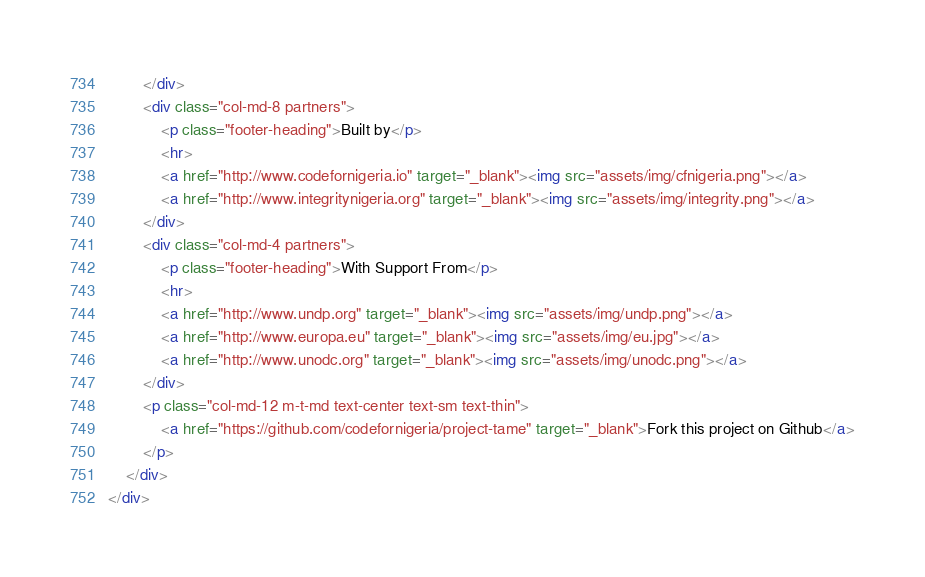<code> <loc_0><loc_0><loc_500><loc_500><_HTML_>		</div>
		<div class="col-md-8 partners">
			<p class="footer-heading">Built by</p>
			<hr>
			<a href="http://www.codefornigeria.io" target="_blank"><img src="assets/img/cfnigeria.png"></a>
			<a href="http://www.integritynigeria.org" target="_blank"><img src="assets/img/integrity.png"></a>
		</div>
		<div class="col-md-4 partners">
			<p class="footer-heading">With Support From</p>
			<hr>
			<a href="http://www.undp.org" target="_blank"><img src="assets/img/undp.png"></a>
			<a href="http://www.europa.eu" target="_blank"><img src="assets/img/eu.jpg"></a>
			<a href="http://www.unodc.org" target="_blank"><img src="assets/img/unodc.png"></a>
		</div>
		<p class="col-md-12 m-t-md text-center text-sm text-thin">
			<a href="https://github.com/codefornigeria/project-tame" target="_blank">Fork this project on Github</a>
		</p>
	</div>
</div>
</code> 